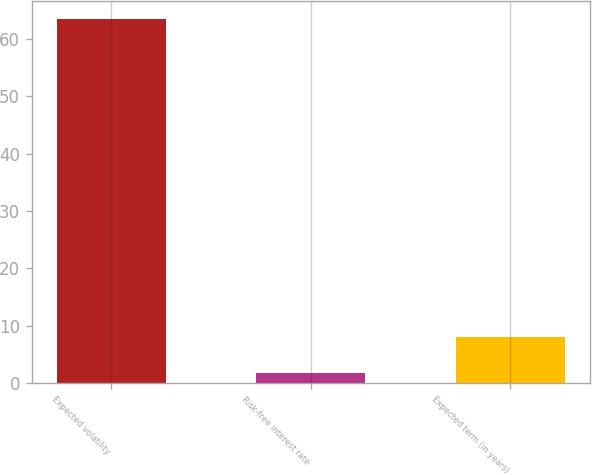Convert chart. <chart><loc_0><loc_0><loc_500><loc_500><bar_chart><fcel>Expected volatility<fcel>Risk-free interest rate<fcel>Expected term (in years)<nl><fcel>63.5<fcel>1.8<fcel>7.97<nl></chart> 